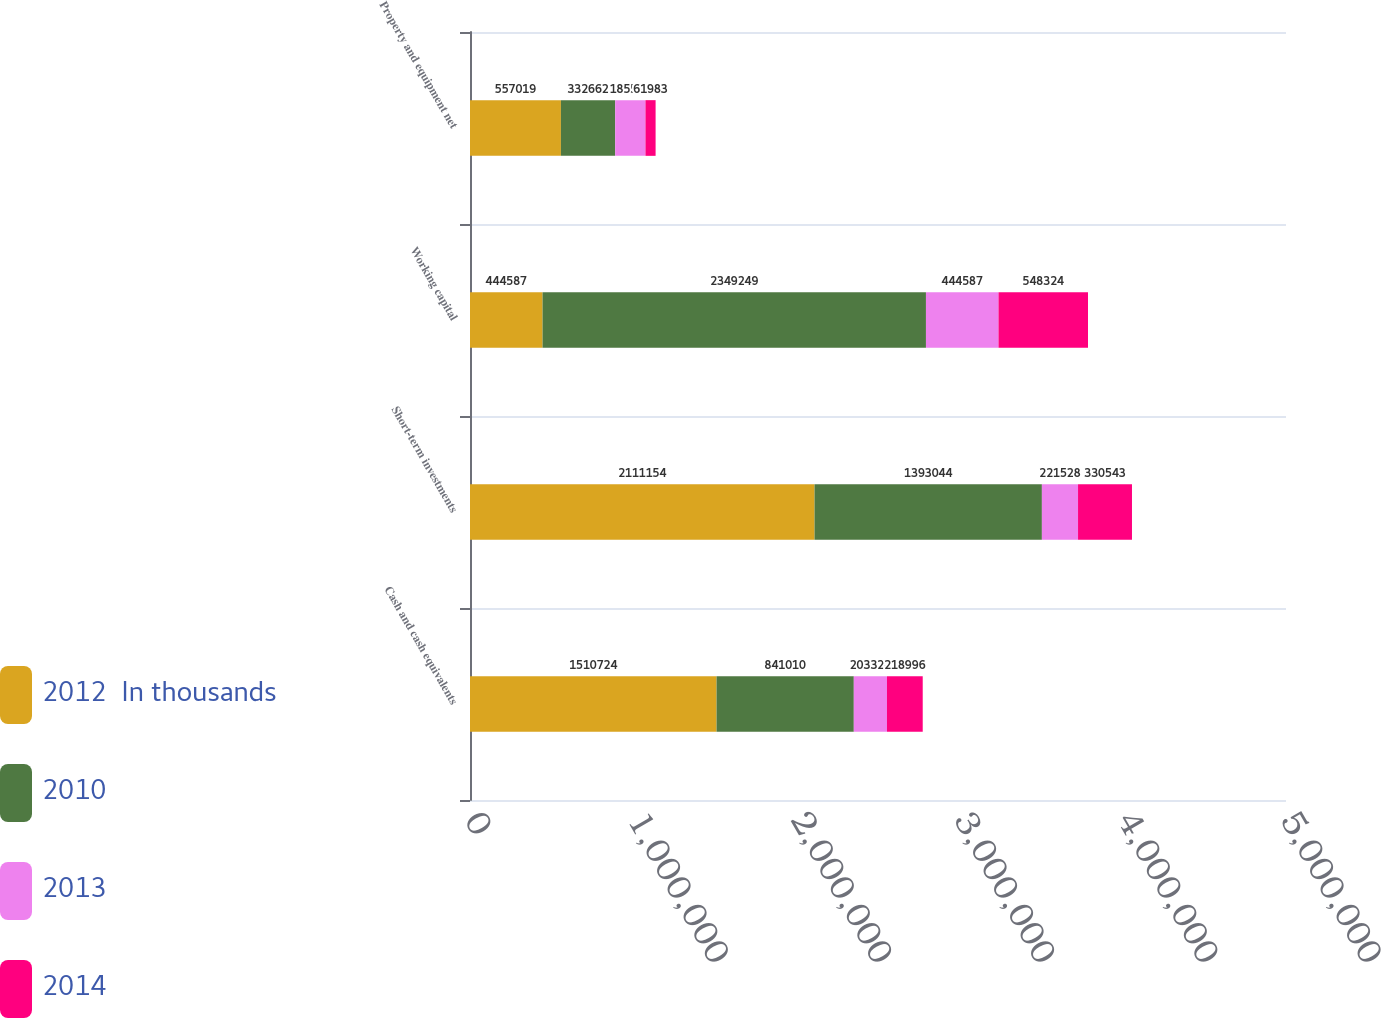Convert chart to OTSL. <chart><loc_0><loc_0><loc_500><loc_500><stacked_bar_chart><ecel><fcel>Cash and cash equivalents<fcel>Short-term investments<fcel>Working capital<fcel>Property and equipment net<nl><fcel>2012  In thousands<fcel>1.51072e+06<fcel>2.11115e+06<fcel>444587<fcel>557019<nl><fcel>2010<fcel>841010<fcel>1.39304e+06<fcel>2.34925e+06<fcel>332662<nl><fcel>2013<fcel>203328<fcel>221528<fcel>444587<fcel>185574<nl><fcel>2014<fcel>218996<fcel>330543<fcel>548324<fcel>61983<nl></chart> 